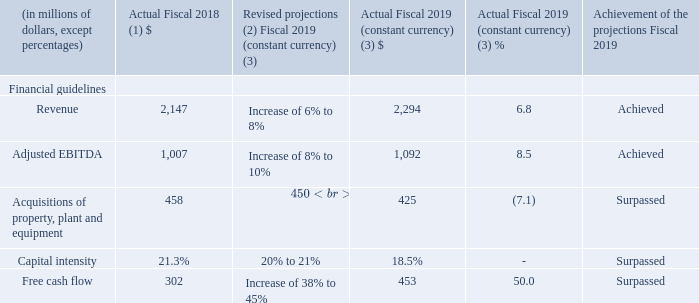2.4 KEY PERFORMANCE INDICATORS AND PERFORMANCE HIGHLIGHTS
The following key performance indicators are closely monitored to ensure that business strategies and objectives are closely aligned with shareholder value creation. The key performance indicators are not measurements in accordance with IFRS and should not be considered an alternative to other measures of performance in accordance with IFRS. The Corporation's method of calculating key performance indicators may differ from other companies and, accordingly, these key performance indicators may not be comparable to similar measures presented by other companies. The Corporation measures its performance, with regard to these objectives by monitoring revenue, adjusted EBITDA(1), free cash flow(1) and capital intensity(1) on a constant currency basis(1).
(1) Fiscal 2018 was restated to comply with IFRS 15 and to reflect a change in accounting policy as well as to reclassify results from Cogeco Peer 1 as discontinued operations. For further details, please consult the "Accounting policies" and "Discontinued operations" sections.
(2) Following the announcement of the agreement on February 27, 2019 to sell Cogeco Peer 1, fiscal 2019 financial guidelines were revised.
(3) Actual results are presented in constant currency based on fiscal 2018 average foreign exchange rates of 1.2773 USD/CDN.
For further details on the Corporation's operating results, please refer to the "Operating and financial results", the "Segmented operating and financial results" and the "Cash flow analysis" sections.
How does the corporation measure its performance? The corporation measures its performance, with regard to these objectives by monitoring revenue, adjusted ebitda(1), free cash flow(1) and capital intensity(1) on a constant currency basis(1). When were the fiscal 2019 financial guidelines revised? February 27, 2019. What was the status of achievement of projections in 2019 for revenue? Achieved. What was the increase / (decrease) in the revenue from 2018 to 2019?
Answer scale should be: million. 2,294 - 2,147
Answer: 147. What was the average Adjusted EBITDA between 2018 to 2019?
Answer scale should be: million. (1,007 + 1,092) / 2
Answer: 1049.5. What was the increase / (decrease) in Free Cash flow from 2018 to 2019?
Answer scale should be: million. 453 - 302
Answer: 151. 